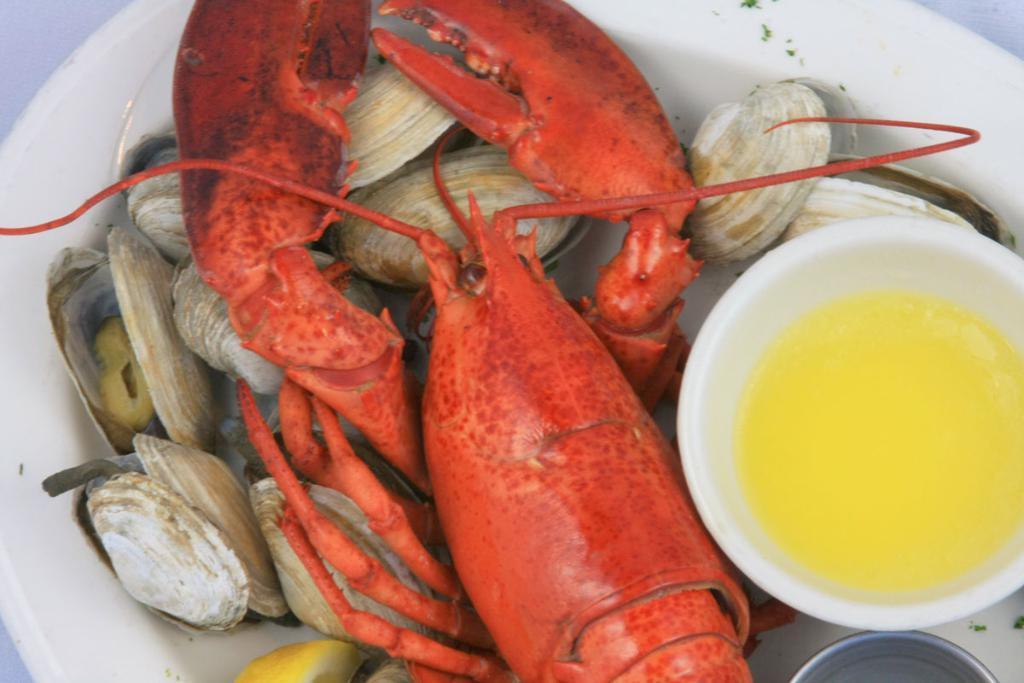In one or two sentences, can you explain what this image depicts? In this image I can see a food in the white color plate. Food is in orange, brown and white color. I can see a bowl and something is in it. 